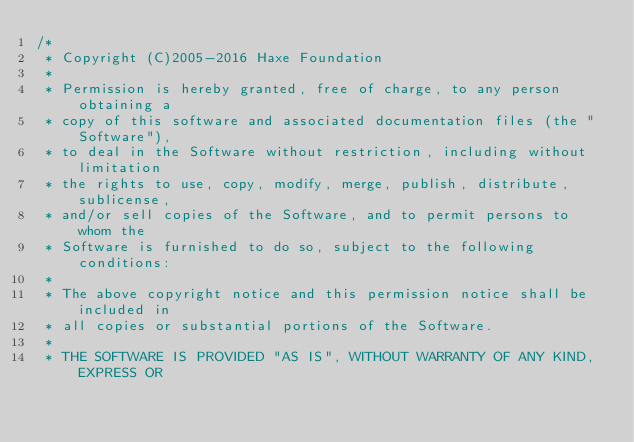Convert code to text. <code><loc_0><loc_0><loc_500><loc_500><_Haxe_>/*
 * Copyright (C)2005-2016 Haxe Foundation
 *
 * Permission is hereby granted, free of charge, to any person obtaining a
 * copy of this software and associated documentation files (the "Software"),
 * to deal in the Software without restriction, including without limitation
 * the rights to use, copy, modify, merge, publish, distribute, sublicense,
 * and/or sell copies of the Software, and to permit persons to whom the
 * Software is furnished to do so, subject to the following conditions:
 *
 * The above copyright notice and this permission notice shall be included in
 * all copies or substantial portions of the Software.
 *
 * THE SOFTWARE IS PROVIDED "AS IS", WITHOUT WARRANTY OF ANY KIND, EXPRESS OR</code> 